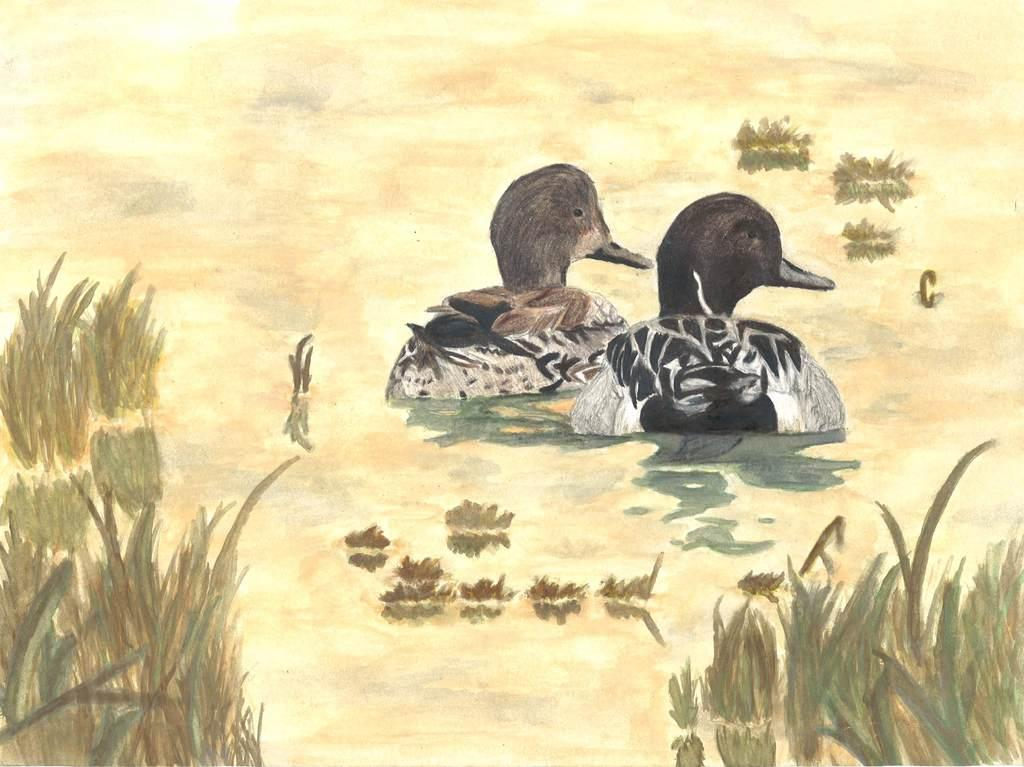What is present on the paper in the image? The paper contains a drawing. What elements are included in the drawing? The drawing depicts grass, water, and ducks. What type of news is being reported on the paper in the image? There is no news being reported on the paper in the image; it contains a drawing of grass, water, and ducks. What kind of bird can be seen in the drawing on the paper? The drawing on the paper depicts ducks, which are not birds in the traditional sense, but rather a specific type of waterfowl. 